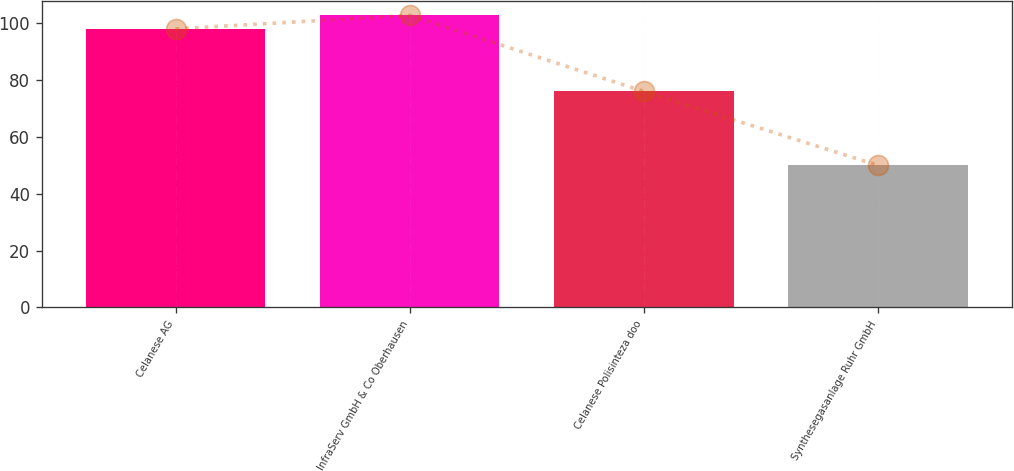Convert chart. <chart><loc_0><loc_0><loc_500><loc_500><bar_chart><fcel>Celanese AG<fcel>InfraServ GmbH & Co Oberhausen<fcel>Celanese Polisinteza doo<fcel>Synthesegasanlage Ruhr GmbH<nl><fcel>98<fcel>102.8<fcel>76<fcel>50<nl></chart> 